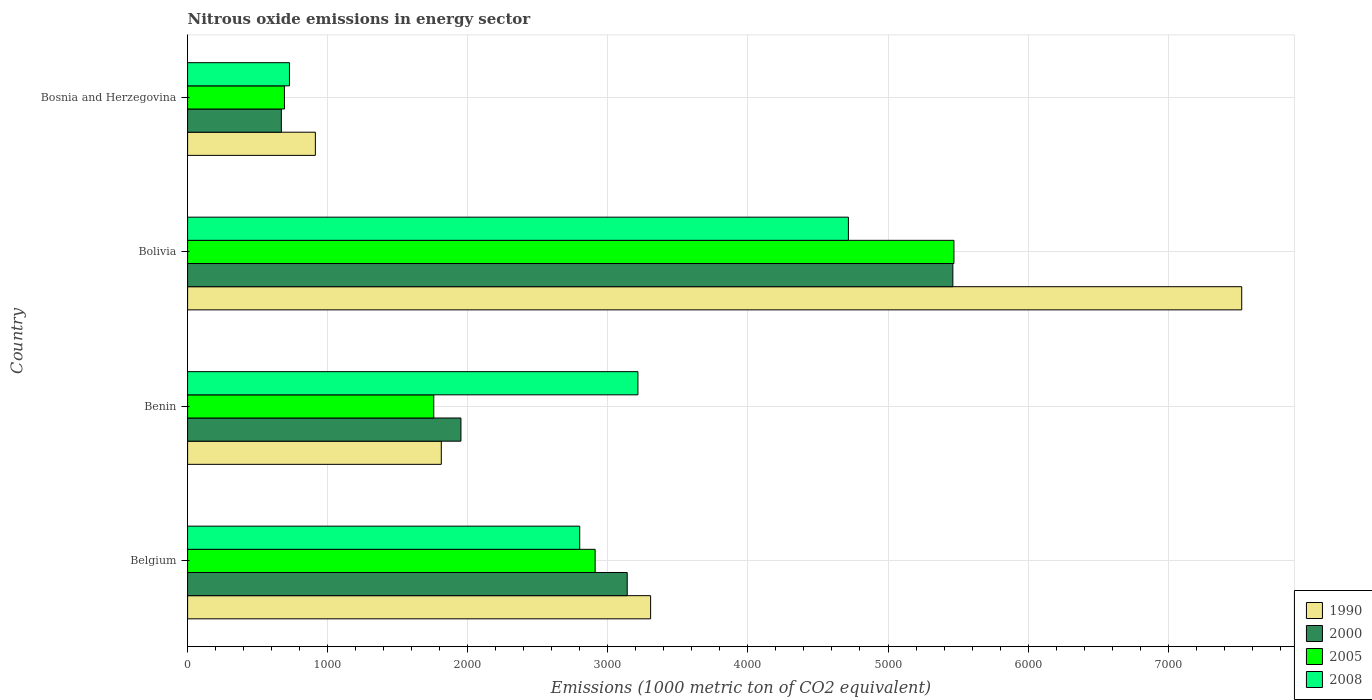How many different coloured bars are there?
Offer a terse response. 4. How many groups of bars are there?
Ensure brevity in your answer.  4. Are the number of bars per tick equal to the number of legend labels?
Keep it short and to the point. Yes. How many bars are there on the 1st tick from the bottom?
Offer a terse response. 4. What is the label of the 1st group of bars from the top?
Keep it short and to the point. Bosnia and Herzegovina. In how many cases, is the number of bars for a given country not equal to the number of legend labels?
Make the answer very short. 0. What is the amount of nitrous oxide emitted in 1990 in Benin?
Make the answer very short. 1811.1. Across all countries, what is the maximum amount of nitrous oxide emitted in 2000?
Offer a very short reply. 5463.1. Across all countries, what is the minimum amount of nitrous oxide emitted in 2000?
Keep it short and to the point. 669.3. In which country was the amount of nitrous oxide emitted in 2008 minimum?
Ensure brevity in your answer.  Bosnia and Herzegovina. What is the total amount of nitrous oxide emitted in 2000 in the graph?
Offer a very short reply. 1.12e+04. What is the difference between the amount of nitrous oxide emitted in 2005 in Bolivia and that in Bosnia and Herzegovina?
Your response must be concise. 4779.5. What is the difference between the amount of nitrous oxide emitted in 2005 in Bosnia and Herzegovina and the amount of nitrous oxide emitted in 2000 in Benin?
Offer a terse response. -1260. What is the average amount of nitrous oxide emitted in 1990 per country?
Offer a very short reply. 3388.48. What is the difference between the amount of nitrous oxide emitted in 1990 and amount of nitrous oxide emitted in 2008 in Belgium?
Ensure brevity in your answer.  506.1. What is the ratio of the amount of nitrous oxide emitted in 1990 in Belgium to that in Benin?
Offer a terse response. 1.83. What is the difference between the highest and the second highest amount of nitrous oxide emitted in 2005?
Offer a terse response. 2561.4. What is the difference between the highest and the lowest amount of nitrous oxide emitted in 2000?
Ensure brevity in your answer.  4793.8. Is it the case that in every country, the sum of the amount of nitrous oxide emitted in 1990 and amount of nitrous oxide emitted in 2000 is greater than the sum of amount of nitrous oxide emitted in 2008 and amount of nitrous oxide emitted in 2005?
Provide a succinct answer. No. What does the 2nd bar from the top in Bosnia and Herzegovina represents?
Offer a terse response. 2005. Is it the case that in every country, the sum of the amount of nitrous oxide emitted in 2005 and amount of nitrous oxide emitted in 2000 is greater than the amount of nitrous oxide emitted in 2008?
Provide a succinct answer. Yes. How many bars are there?
Your answer should be compact. 16. What is the difference between two consecutive major ticks on the X-axis?
Your answer should be compact. 1000. Where does the legend appear in the graph?
Your response must be concise. Bottom right. How are the legend labels stacked?
Your response must be concise. Vertical. What is the title of the graph?
Give a very brief answer. Nitrous oxide emissions in energy sector. What is the label or title of the X-axis?
Your answer should be compact. Emissions (1000 metric ton of CO2 equivalent). What is the label or title of the Y-axis?
Your response must be concise. Country. What is the Emissions (1000 metric ton of CO2 equivalent) of 1990 in Belgium?
Give a very brief answer. 3305.4. What is the Emissions (1000 metric ton of CO2 equivalent) in 2000 in Belgium?
Offer a very short reply. 3138.4. What is the Emissions (1000 metric ton of CO2 equivalent) in 2005 in Belgium?
Ensure brevity in your answer.  2909.4. What is the Emissions (1000 metric ton of CO2 equivalent) in 2008 in Belgium?
Your response must be concise. 2799.3. What is the Emissions (1000 metric ton of CO2 equivalent) of 1990 in Benin?
Offer a very short reply. 1811.1. What is the Emissions (1000 metric ton of CO2 equivalent) in 2000 in Benin?
Make the answer very short. 1951.3. What is the Emissions (1000 metric ton of CO2 equivalent) in 2005 in Benin?
Offer a very short reply. 1757.4. What is the Emissions (1000 metric ton of CO2 equivalent) in 2008 in Benin?
Provide a succinct answer. 3214.8. What is the Emissions (1000 metric ton of CO2 equivalent) in 1990 in Bolivia?
Provide a short and direct response. 7525.2. What is the Emissions (1000 metric ton of CO2 equivalent) in 2000 in Bolivia?
Give a very brief answer. 5463.1. What is the Emissions (1000 metric ton of CO2 equivalent) in 2005 in Bolivia?
Offer a terse response. 5470.8. What is the Emissions (1000 metric ton of CO2 equivalent) in 2008 in Bolivia?
Ensure brevity in your answer.  4717.4. What is the Emissions (1000 metric ton of CO2 equivalent) of 1990 in Bosnia and Herzegovina?
Your answer should be very brief. 912.2. What is the Emissions (1000 metric ton of CO2 equivalent) in 2000 in Bosnia and Herzegovina?
Make the answer very short. 669.3. What is the Emissions (1000 metric ton of CO2 equivalent) of 2005 in Bosnia and Herzegovina?
Provide a succinct answer. 691.3. What is the Emissions (1000 metric ton of CO2 equivalent) of 2008 in Bosnia and Herzegovina?
Provide a short and direct response. 727.1. Across all countries, what is the maximum Emissions (1000 metric ton of CO2 equivalent) of 1990?
Your response must be concise. 7525.2. Across all countries, what is the maximum Emissions (1000 metric ton of CO2 equivalent) in 2000?
Offer a very short reply. 5463.1. Across all countries, what is the maximum Emissions (1000 metric ton of CO2 equivalent) in 2005?
Offer a very short reply. 5470.8. Across all countries, what is the maximum Emissions (1000 metric ton of CO2 equivalent) in 2008?
Offer a terse response. 4717.4. Across all countries, what is the minimum Emissions (1000 metric ton of CO2 equivalent) of 1990?
Make the answer very short. 912.2. Across all countries, what is the minimum Emissions (1000 metric ton of CO2 equivalent) in 2000?
Your answer should be compact. 669.3. Across all countries, what is the minimum Emissions (1000 metric ton of CO2 equivalent) of 2005?
Your response must be concise. 691.3. Across all countries, what is the minimum Emissions (1000 metric ton of CO2 equivalent) of 2008?
Offer a very short reply. 727.1. What is the total Emissions (1000 metric ton of CO2 equivalent) in 1990 in the graph?
Ensure brevity in your answer.  1.36e+04. What is the total Emissions (1000 metric ton of CO2 equivalent) in 2000 in the graph?
Your answer should be very brief. 1.12e+04. What is the total Emissions (1000 metric ton of CO2 equivalent) of 2005 in the graph?
Your answer should be compact. 1.08e+04. What is the total Emissions (1000 metric ton of CO2 equivalent) in 2008 in the graph?
Provide a short and direct response. 1.15e+04. What is the difference between the Emissions (1000 metric ton of CO2 equivalent) of 1990 in Belgium and that in Benin?
Give a very brief answer. 1494.3. What is the difference between the Emissions (1000 metric ton of CO2 equivalent) in 2000 in Belgium and that in Benin?
Ensure brevity in your answer.  1187.1. What is the difference between the Emissions (1000 metric ton of CO2 equivalent) of 2005 in Belgium and that in Benin?
Make the answer very short. 1152. What is the difference between the Emissions (1000 metric ton of CO2 equivalent) in 2008 in Belgium and that in Benin?
Offer a terse response. -415.5. What is the difference between the Emissions (1000 metric ton of CO2 equivalent) of 1990 in Belgium and that in Bolivia?
Offer a terse response. -4219.8. What is the difference between the Emissions (1000 metric ton of CO2 equivalent) of 2000 in Belgium and that in Bolivia?
Ensure brevity in your answer.  -2324.7. What is the difference between the Emissions (1000 metric ton of CO2 equivalent) of 2005 in Belgium and that in Bolivia?
Make the answer very short. -2561.4. What is the difference between the Emissions (1000 metric ton of CO2 equivalent) of 2008 in Belgium and that in Bolivia?
Provide a short and direct response. -1918.1. What is the difference between the Emissions (1000 metric ton of CO2 equivalent) in 1990 in Belgium and that in Bosnia and Herzegovina?
Provide a succinct answer. 2393.2. What is the difference between the Emissions (1000 metric ton of CO2 equivalent) in 2000 in Belgium and that in Bosnia and Herzegovina?
Offer a very short reply. 2469.1. What is the difference between the Emissions (1000 metric ton of CO2 equivalent) of 2005 in Belgium and that in Bosnia and Herzegovina?
Provide a short and direct response. 2218.1. What is the difference between the Emissions (1000 metric ton of CO2 equivalent) in 2008 in Belgium and that in Bosnia and Herzegovina?
Your response must be concise. 2072.2. What is the difference between the Emissions (1000 metric ton of CO2 equivalent) in 1990 in Benin and that in Bolivia?
Make the answer very short. -5714.1. What is the difference between the Emissions (1000 metric ton of CO2 equivalent) in 2000 in Benin and that in Bolivia?
Provide a short and direct response. -3511.8. What is the difference between the Emissions (1000 metric ton of CO2 equivalent) of 2005 in Benin and that in Bolivia?
Provide a short and direct response. -3713.4. What is the difference between the Emissions (1000 metric ton of CO2 equivalent) in 2008 in Benin and that in Bolivia?
Offer a terse response. -1502.6. What is the difference between the Emissions (1000 metric ton of CO2 equivalent) of 1990 in Benin and that in Bosnia and Herzegovina?
Ensure brevity in your answer.  898.9. What is the difference between the Emissions (1000 metric ton of CO2 equivalent) in 2000 in Benin and that in Bosnia and Herzegovina?
Ensure brevity in your answer.  1282. What is the difference between the Emissions (1000 metric ton of CO2 equivalent) in 2005 in Benin and that in Bosnia and Herzegovina?
Offer a very short reply. 1066.1. What is the difference between the Emissions (1000 metric ton of CO2 equivalent) of 2008 in Benin and that in Bosnia and Herzegovina?
Provide a short and direct response. 2487.7. What is the difference between the Emissions (1000 metric ton of CO2 equivalent) of 1990 in Bolivia and that in Bosnia and Herzegovina?
Your answer should be very brief. 6613. What is the difference between the Emissions (1000 metric ton of CO2 equivalent) of 2000 in Bolivia and that in Bosnia and Herzegovina?
Make the answer very short. 4793.8. What is the difference between the Emissions (1000 metric ton of CO2 equivalent) in 2005 in Bolivia and that in Bosnia and Herzegovina?
Your response must be concise. 4779.5. What is the difference between the Emissions (1000 metric ton of CO2 equivalent) of 2008 in Bolivia and that in Bosnia and Herzegovina?
Provide a short and direct response. 3990.3. What is the difference between the Emissions (1000 metric ton of CO2 equivalent) in 1990 in Belgium and the Emissions (1000 metric ton of CO2 equivalent) in 2000 in Benin?
Make the answer very short. 1354.1. What is the difference between the Emissions (1000 metric ton of CO2 equivalent) in 1990 in Belgium and the Emissions (1000 metric ton of CO2 equivalent) in 2005 in Benin?
Offer a very short reply. 1548. What is the difference between the Emissions (1000 metric ton of CO2 equivalent) of 1990 in Belgium and the Emissions (1000 metric ton of CO2 equivalent) of 2008 in Benin?
Provide a short and direct response. 90.6. What is the difference between the Emissions (1000 metric ton of CO2 equivalent) of 2000 in Belgium and the Emissions (1000 metric ton of CO2 equivalent) of 2005 in Benin?
Provide a succinct answer. 1381. What is the difference between the Emissions (1000 metric ton of CO2 equivalent) of 2000 in Belgium and the Emissions (1000 metric ton of CO2 equivalent) of 2008 in Benin?
Make the answer very short. -76.4. What is the difference between the Emissions (1000 metric ton of CO2 equivalent) in 2005 in Belgium and the Emissions (1000 metric ton of CO2 equivalent) in 2008 in Benin?
Keep it short and to the point. -305.4. What is the difference between the Emissions (1000 metric ton of CO2 equivalent) of 1990 in Belgium and the Emissions (1000 metric ton of CO2 equivalent) of 2000 in Bolivia?
Provide a succinct answer. -2157.7. What is the difference between the Emissions (1000 metric ton of CO2 equivalent) in 1990 in Belgium and the Emissions (1000 metric ton of CO2 equivalent) in 2005 in Bolivia?
Your answer should be very brief. -2165.4. What is the difference between the Emissions (1000 metric ton of CO2 equivalent) in 1990 in Belgium and the Emissions (1000 metric ton of CO2 equivalent) in 2008 in Bolivia?
Provide a succinct answer. -1412. What is the difference between the Emissions (1000 metric ton of CO2 equivalent) of 2000 in Belgium and the Emissions (1000 metric ton of CO2 equivalent) of 2005 in Bolivia?
Keep it short and to the point. -2332.4. What is the difference between the Emissions (1000 metric ton of CO2 equivalent) in 2000 in Belgium and the Emissions (1000 metric ton of CO2 equivalent) in 2008 in Bolivia?
Your answer should be compact. -1579. What is the difference between the Emissions (1000 metric ton of CO2 equivalent) of 2005 in Belgium and the Emissions (1000 metric ton of CO2 equivalent) of 2008 in Bolivia?
Offer a very short reply. -1808. What is the difference between the Emissions (1000 metric ton of CO2 equivalent) of 1990 in Belgium and the Emissions (1000 metric ton of CO2 equivalent) of 2000 in Bosnia and Herzegovina?
Provide a short and direct response. 2636.1. What is the difference between the Emissions (1000 metric ton of CO2 equivalent) in 1990 in Belgium and the Emissions (1000 metric ton of CO2 equivalent) in 2005 in Bosnia and Herzegovina?
Make the answer very short. 2614.1. What is the difference between the Emissions (1000 metric ton of CO2 equivalent) of 1990 in Belgium and the Emissions (1000 metric ton of CO2 equivalent) of 2008 in Bosnia and Herzegovina?
Give a very brief answer. 2578.3. What is the difference between the Emissions (1000 metric ton of CO2 equivalent) of 2000 in Belgium and the Emissions (1000 metric ton of CO2 equivalent) of 2005 in Bosnia and Herzegovina?
Make the answer very short. 2447.1. What is the difference between the Emissions (1000 metric ton of CO2 equivalent) of 2000 in Belgium and the Emissions (1000 metric ton of CO2 equivalent) of 2008 in Bosnia and Herzegovina?
Provide a short and direct response. 2411.3. What is the difference between the Emissions (1000 metric ton of CO2 equivalent) of 2005 in Belgium and the Emissions (1000 metric ton of CO2 equivalent) of 2008 in Bosnia and Herzegovina?
Your answer should be very brief. 2182.3. What is the difference between the Emissions (1000 metric ton of CO2 equivalent) of 1990 in Benin and the Emissions (1000 metric ton of CO2 equivalent) of 2000 in Bolivia?
Make the answer very short. -3652. What is the difference between the Emissions (1000 metric ton of CO2 equivalent) in 1990 in Benin and the Emissions (1000 metric ton of CO2 equivalent) in 2005 in Bolivia?
Make the answer very short. -3659.7. What is the difference between the Emissions (1000 metric ton of CO2 equivalent) in 1990 in Benin and the Emissions (1000 metric ton of CO2 equivalent) in 2008 in Bolivia?
Give a very brief answer. -2906.3. What is the difference between the Emissions (1000 metric ton of CO2 equivalent) in 2000 in Benin and the Emissions (1000 metric ton of CO2 equivalent) in 2005 in Bolivia?
Give a very brief answer. -3519.5. What is the difference between the Emissions (1000 metric ton of CO2 equivalent) of 2000 in Benin and the Emissions (1000 metric ton of CO2 equivalent) of 2008 in Bolivia?
Provide a short and direct response. -2766.1. What is the difference between the Emissions (1000 metric ton of CO2 equivalent) of 2005 in Benin and the Emissions (1000 metric ton of CO2 equivalent) of 2008 in Bolivia?
Offer a terse response. -2960. What is the difference between the Emissions (1000 metric ton of CO2 equivalent) of 1990 in Benin and the Emissions (1000 metric ton of CO2 equivalent) of 2000 in Bosnia and Herzegovina?
Your answer should be compact. 1141.8. What is the difference between the Emissions (1000 metric ton of CO2 equivalent) of 1990 in Benin and the Emissions (1000 metric ton of CO2 equivalent) of 2005 in Bosnia and Herzegovina?
Keep it short and to the point. 1119.8. What is the difference between the Emissions (1000 metric ton of CO2 equivalent) in 1990 in Benin and the Emissions (1000 metric ton of CO2 equivalent) in 2008 in Bosnia and Herzegovina?
Give a very brief answer. 1084. What is the difference between the Emissions (1000 metric ton of CO2 equivalent) of 2000 in Benin and the Emissions (1000 metric ton of CO2 equivalent) of 2005 in Bosnia and Herzegovina?
Provide a succinct answer. 1260. What is the difference between the Emissions (1000 metric ton of CO2 equivalent) of 2000 in Benin and the Emissions (1000 metric ton of CO2 equivalent) of 2008 in Bosnia and Herzegovina?
Keep it short and to the point. 1224.2. What is the difference between the Emissions (1000 metric ton of CO2 equivalent) of 2005 in Benin and the Emissions (1000 metric ton of CO2 equivalent) of 2008 in Bosnia and Herzegovina?
Your answer should be compact. 1030.3. What is the difference between the Emissions (1000 metric ton of CO2 equivalent) of 1990 in Bolivia and the Emissions (1000 metric ton of CO2 equivalent) of 2000 in Bosnia and Herzegovina?
Keep it short and to the point. 6855.9. What is the difference between the Emissions (1000 metric ton of CO2 equivalent) of 1990 in Bolivia and the Emissions (1000 metric ton of CO2 equivalent) of 2005 in Bosnia and Herzegovina?
Your answer should be compact. 6833.9. What is the difference between the Emissions (1000 metric ton of CO2 equivalent) in 1990 in Bolivia and the Emissions (1000 metric ton of CO2 equivalent) in 2008 in Bosnia and Herzegovina?
Ensure brevity in your answer.  6798.1. What is the difference between the Emissions (1000 metric ton of CO2 equivalent) in 2000 in Bolivia and the Emissions (1000 metric ton of CO2 equivalent) in 2005 in Bosnia and Herzegovina?
Ensure brevity in your answer.  4771.8. What is the difference between the Emissions (1000 metric ton of CO2 equivalent) in 2000 in Bolivia and the Emissions (1000 metric ton of CO2 equivalent) in 2008 in Bosnia and Herzegovina?
Your answer should be very brief. 4736. What is the difference between the Emissions (1000 metric ton of CO2 equivalent) of 2005 in Bolivia and the Emissions (1000 metric ton of CO2 equivalent) of 2008 in Bosnia and Herzegovina?
Your answer should be very brief. 4743.7. What is the average Emissions (1000 metric ton of CO2 equivalent) in 1990 per country?
Offer a terse response. 3388.47. What is the average Emissions (1000 metric ton of CO2 equivalent) of 2000 per country?
Make the answer very short. 2805.53. What is the average Emissions (1000 metric ton of CO2 equivalent) in 2005 per country?
Your answer should be very brief. 2707.22. What is the average Emissions (1000 metric ton of CO2 equivalent) of 2008 per country?
Offer a terse response. 2864.65. What is the difference between the Emissions (1000 metric ton of CO2 equivalent) in 1990 and Emissions (1000 metric ton of CO2 equivalent) in 2000 in Belgium?
Your answer should be compact. 167. What is the difference between the Emissions (1000 metric ton of CO2 equivalent) in 1990 and Emissions (1000 metric ton of CO2 equivalent) in 2005 in Belgium?
Ensure brevity in your answer.  396. What is the difference between the Emissions (1000 metric ton of CO2 equivalent) in 1990 and Emissions (1000 metric ton of CO2 equivalent) in 2008 in Belgium?
Your answer should be very brief. 506.1. What is the difference between the Emissions (1000 metric ton of CO2 equivalent) in 2000 and Emissions (1000 metric ton of CO2 equivalent) in 2005 in Belgium?
Offer a terse response. 229. What is the difference between the Emissions (1000 metric ton of CO2 equivalent) of 2000 and Emissions (1000 metric ton of CO2 equivalent) of 2008 in Belgium?
Your answer should be very brief. 339.1. What is the difference between the Emissions (1000 metric ton of CO2 equivalent) in 2005 and Emissions (1000 metric ton of CO2 equivalent) in 2008 in Belgium?
Offer a terse response. 110.1. What is the difference between the Emissions (1000 metric ton of CO2 equivalent) of 1990 and Emissions (1000 metric ton of CO2 equivalent) of 2000 in Benin?
Give a very brief answer. -140.2. What is the difference between the Emissions (1000 metric ton of CO2 equivalent) in 1990 and Emissions (1000 metric ton of CO2 equivalent) in 2005 in Benin?
Offer a very short reply. 53.7. What is the difference between the Emissions (1000 metric ton of CO2 equivalent) of 1990 and Emissions (1000 metric ton of CO2 equivalent) of 2008 in Benin?
Give a very brief answer. -1403.7. What is the difference between the Emissions (1000 metric ton of CO2 equivalent) in 2000 and Emissions (1000 metric ton of CO2 equivalent) in 2005 in Benin?
Your answer should be compact. 193.9. What is the difference between the Emissions (1000 metric ton of CO2 equivalent) of 2000 and Emissions (1000 metric ton of CO2 equivalent) of 2008 in Benin?
Make the answer very short. -1263.5. What is the difference between the Emissions (1000 metric ton of CO2 equivalent) in 2005 and Emissions (1000 metric ton of CO2 equivalent) in 2008 in Benin?
Ensure brevity in your answer.  -1457.4. What is the difference between the Emissions (1000 metric ton of CO2 equivalent) of 1990 and Emissions (1000 metric ton of CO2 equivalent) of 2000 in Bolivia?
Ensure brevity in your answer.  2062.1. What is the difference between the Emissions (1000 metric ton of CO2 equivalent) of 1990 and Emissions (1000 metric ton of CO2 equivalent) of 2005 in Bolivia?
Provide a short and direct response. 2054.4. What is the difference between the Emissions (1000 metric ton of CO2 equivalent) of 1990 and Emissions (1000 metric ton of CO2 equivalent) of 2008 in Bolivia?
Offer a very short reply. 2807.8. What is the difference between the Emissions (1000 metric ton of CO2 equivalent) in 2000 and Emissions (1000 metric ton of CO2 equivalent) in 2008 in Bolivia?
Provide a succinct answer. 745.7. What is the difference between the Emissions (1000 metric ton of CO2 equivalent) in 2005 and Emissions (1000 metric ton of CO2 equivalent) in 2008 in Bolivia?
Provide a succinct answer. 753.4. What is the difference between the Emissions (1000 metric ton of CO2 equivalent) in 1990 and Emissions (1000 metric ton of CO2 equivalent) in 2000 in Bosnia and Herzegovina?
Ensure brevity in your answer.  242.9. What is the difference between the Emissions (1000 metric ton of CO2 equivalent) of 1990 and Emissions (1000 metric ton of CO2 equivalent) of 2005 in Bosnia and Herzegovina?
Ensure brevity in your answer.  220.9. What is the difference between the Emissions (1000 metric ton of CO2 equivalent) of 1990 and Emissions (1000 metric ton of CO2 equivalent) of 2008 in Bosnia and Herzegovina?
Make the answer very short. 185.1. What is the difference between the Emissions (1000 metric ton of CO2 equivalent) of 2000 and Emissions (1000 metric ton of CO2 equivalent) of 2008 in Bosnia and Herzegovina?
Provide a succinct answer. -57.8. What is the difference between the Emissions (1000 metric ton of CO2 equivalent) in 2005 and Emissions (1000 metric ton of CO2 equivalent) in 2008 in Bosnia and Herzegovina?
Provide a succinct answer. -35.8. What is the ratio of the Emissions (1000 metric ton of CO2 equivalent) of 1990 in Belgium to that in Benin?
Your answer should be compact. 1.83. What is the ratio of the Emissions (1000 metric ton of CO2 equivalent) of 2000 in Belgium to that in Benin?
Offer a very short reply. 1.61. What is the ratio of the Emissions (1000 metric ton of CO2 equivalent) in 2005 in Belgium to that in Benin?
Provide a short and direct response. 1.66. What is the ratio of the Emissions (1000 metric ton of CO2 equivalent) of 2008 in Belgium to that in Benin?
Keep it short and to the point. 0.87. What is the ratio of the Emissions (1000 metric ton of CO2 equivalent) of 1990 in Belgium to that in Bolivia?
Offer a very short reply. 0.44. What is the ratio of the Emissions (1000 metric ton of CO2 equivalent) of 2000 in Belgium to that in Bolivia?
Make the answer very short. 0.57. What is the ratio of the Emissions (1000 metric ton of CO2 equivalent) in 2005 in Belgium to that in Bolivia?
Ensure brevity in your answer.  0.53. What is the ratio of the Emissions (1000 metric ton of CO2 equivalent) in 2008 in Belgium to that in Bolivia?
Give a very brief answer. 0.59. What is the ratio of the Emissions (1000 metric ton of CO2 equivalent) of 1990 in Belgium to that in Bosnia and Herzegovina?
Provide a succinct answer. 3.62. What is the ratio of the Emissions (1000 metric ton of CO2 equivalent) in 2000 in Belgium to that in Bosnia and Herzegovina?
Provide a short and direct response. 4.69. What is the ratio of the Emissions (1000 metric ton of CO2 equivalent) in 2005 in Belgium to that in Bosnia and Herzegovina?
Ensure brevity in your answer.  4.21. What is the ratio of the Emissions (1000 metric ton of CO2 equivalent) in 2008 in Belgium to that in Bosnia and Herzegovina?
Make the answer very short. 3.85. What is the ratio of the Emissions (1000 metric ton of CO2 equivalent) in 1990 in Benin to that in Bolivia?
Offer a terse response. 0.24. What is the ratio of the Emissions (1000 metric ton of CO2 equivalent) of 2000 in Benin to that in Bolivia?
Give a very brief answer. 0.36. What is the ratio of the Emissions (1000 metric ton of CO2 equivalent) in 2005 in Benin to that in Bolivia?
Ensure brevity in your answer.  0.32. What is the ratio of the Emissions (1000 metric ton of CO2 equivalent) in 2008 in Benin to that in Bolivia?
Make the answer very short. 0.68. What is the ratio of the Emissions (1000 metric ton of CO2 equivalent) of 1990 in Benin to that in Bosnia and Herzegovina?
Provide a short and direct response. 1.99. What is the ratio of the Emissions (1000 metric ton of CO2 equivalent) in 2000 in Benin to that in Bosnia and Herzegovina?
Provide a short and direct response. 2.92. What is the ratio of the Emissions (1000 metric ton of CO2 equivalent) of 2005 in Benin to that in Bosnia and Herzegovina?
Give a very brief answer. 2.54. What is the ratio of the Emissions (1000 metric ton of CO2 equivalent) in 2008 in Benin to that in Bosnia and Herzegovina?
Give a very brief answer. 4.42. What is the ratio of the Emissions (1000 metric ton of CO2 equivalent) in 1990 in Bolivia to that in Bosnia and Herzegovina?
Ensure brevity in your answer.  8.25. What is the ratio of the Emissions (1000 metric ton of CO2 equivalent) of 2000 in Bolivia to that in Bosnia and Herzegovina?
Offer a terse response. 8.16. What is the ratio of the Emissions (1000 metric ton of CO2 equivalent) in 2005 in Bolivia to that in Bosnia and Herzegovina?
Provide a short and direct response. 7.91. What is the ratio of the Emissions (1000 metric ton of CO2 equivalent) in 2008 in Bolivia to that in Bosnia and Herzegovina?
Your response must be concise. 6.49. What is the difference between the highest and the second highest Emissions (1000 metric ton of CO2 equivalent) in 1990?
Give a very brief answer. 4219.8. What is the difference between the highest and the second highest Emissions (1000 metric ton of CO2 equivalent) in 2000?
Provide a short and direct response. 2324.7. What is the difference between the highest and the second highest Emissions (1000 metric ton of CO2 equivalent) in 2005?
Ensure brevity in your answer.  2561.4. What is the difference between the highest and the second highest Emissions (1000 metric ton of CO2 equivalent) in 2008?
Make the answer very short. 1502.6. What is the difference between the highest and the lowest Emissions (1000 metric ton of CO2 equivalent) in 1990?
Provide a succinct answer. 6613. What is the difference between the highest and the lowest Emissions (1000 metric ton of CO2 equivalent) in 2000?
Give a very brief answer. 4793.8. What is the difference between the highest and the lowest Emissions (1000 metric ton of CO2 equivalent) in 2005?
Your answer should be very brief. 4779.5. What is the difference between the highest and the lowest Emissions (1000 metric ton of CO2 equivalent) in 2008?
Ensure brevity in your answer.  3990.3. 